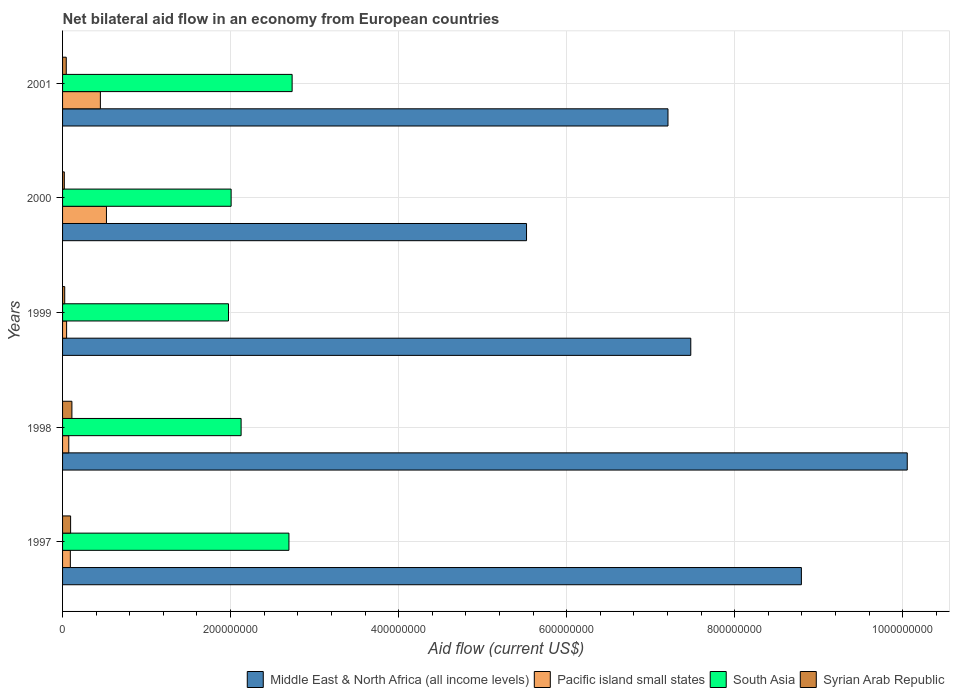How many different coloured bars are there?
Keep it short and to the point. 4. How many groups of bars are there?
Ensure brevity in your answer.  5. Are the number of bars on each tick of the Y-axis equal?
Ensure brevity in your answer.  Yes. How many bars are there on the 4th tick from the top?
Make the answer very short. 4. In how many cases, is the number of bars for a given year not equal to the number of legend labels?
Ensure brevity in your answer.  0. What is the net bilateral aid flow in Pacific island small states in 2001?
Provide a succinct answer. 4.50e+07. Across all years, what is the maximum net bilateral aid flow in Pacific island small states?
Give a very brief answer. 5.22e+07. Across all years, what is the minimum net bilateral aid flow in South Asia?
Offer a terse response. 1.98e+08. In which year was the net bilateral aid flow in South Asia maximum?
Offer a terse response. 2001. In which year was the net bilateral aid flow in Middle East & North Africa (all income levels) minimum?
Keep it short and to the point. 2000. What is the total net bilateral aid flow in Middle East & North Africa (all income levels) in the graph?
Provide a short and direct response. 3.91e+09. What is the difference between the net bilateral aid flow in South Asia in 1997 and that in 1998?
Keep it short and to the point. 5.69e+07. What is the difference between the net bilateral aid flow in Pacific island small states in 1997 and the net bilateral aid flow in Middle East & North Africa (all income levels) in 1999?
Offer a very short reply. -7.39e+08. What is the average net bilateral aid flow in South Asia per year?
Your response must be concise. 2.31e+08. In the year 1997, what is the difference between the net bilateral aid flow in South Asia and net bilateral aid flow in Middle East & North Africa (all income levels)?
Your response must be concise. -6.10e+08. What is the ratio of the net bilateral aid flow in Middle East & North Africa (all income levels) in 1999 to that in 2001?
Your answer should be compact. 1.04. Is the net bilateral aid flow in South Asia in 1997 less than that in 1998?
Make the answer very short. No. What is the difference between the highest and the second highest net bilateral aid flow in Pacific island small states?
Provide a succinct answer. 7.24e+06. What is the difference between the highest and the lowest net bilateral aid flow in Middle East & North Africa (all income levels)?
Your answer should be very brief. 4.53e+08. Is the sum of the net bilateral aid flow in Middle East & North Africa (all income levels) in 2000 and 2001 greater than the maximum net bilateral aid flow in Syrian Arab Republic across all years?
Provide a short and direct response. Yes. Is it the case that in every year, the sum of the net bilateral aid flow in Middle East & North Africa (all income levels) and net bilateral aid flow in Pacific island small states is greater than the sum of net bilateral aid flow in South Asia and net bilateral aid flow in Syrian Arab Republic?
Offer a terse response. No. What does the 1st bar from the top in 1998 represents?
Offer a very short reply. Syrian Arab Republic. What does the 1st bar from the bottom in 2000 represents?
Give a very brief answer. Middle East & North Africa (all income levels). How many bars are there?
Provide a short and direct response. 20. Does the graph contain any zero values?
Provide a short and direct response. No. How are the legend labels stacked?
Offer a very short reply. Horizontal. What is the title of the graph?
Ensure brevity in your answer.  Net bilateral aid flow in an economy from European countries. Does "Namibia" appear as one of the legend labels in the graph?
Provide a succinct answer. No. What is the label or title of the Y-axis?
Your answer should be compact. Years. What is the Aid flow (current US$) in Middle East & North Africa (all income levels) in 1997?
Your answer should be compact. 8.79e+08. What is the Aid flow (current US$) of Pacific island small states in 1997?
Make the answer very short. 9.26e+06. What is the Aid flow (current US$) in South Asia in 1997?
Ensure brevity in your answer.  2.69e+08. What is the Aid flow (current US$) of Syrian Arab Republic in 1997?
Ensure brevity in your answer.  9.58e+06. What is the Aid flow (current US$) in Middle East & North Africa (all income levels) in 1998?
Offer a terse response. 1.01e+09. What is the Aid flow (current US$) in Pacific island small states in 1998?
Give a very brief answer. 7.39e+06. What is the Aid flow (current US$) of South Asia in 1998?
Make the answer very short. 2.13e+08. What is the Aid flow (current US$) in Syrian Arab Republic in 1998?
Keep it short and to the point. 1.11e+07. What is the Aid flow (current US$) of Middle East & North Africa (all income levels) in 1999?
Ensure brevity in your answer.  7.48e+08. What is the Aid flow (current US$) in Pacific island small states in 1999?
Ensure brevity in your answer.  4.82e+06. What is the Aid flow (current US$) in South Asia in 1999?
Offer a terse response. 1.98e+08. What is the Aid flow (current US$) in Syrian Arab Republic in 1999?
Offer a terse response. 2.57e+06. What is the Aid flow (current US$) in Middle East & North Africa (all income levels) in 2000?
Your response must be concise. 5.52e+08. What is the Aid flow (current US$) of Pacific island small states in 2000?
Ensure brevity in your answer.  5.22e+07. What is the Aid flow (current US$) of South Asia in 2000?
Keep it short and to the point. 2.01e+08. What is the Aid flow (current US$) of Syrian Arab Republic in 2000?
Offer a very short reply. 2.08e+06. What is the Aid flow (current US$) in Middle East & North Africa (all income levels) in 2001?
Provide a short and direct response. 7.21e+08. What is the Aid flow (current US$) in Pacific island small states in 2001?
Provide a succinct answer. 4.50e+07. What is the Aid flow (current US$) of South Asia in 2001?
Offer a very short reply. 2.73e+08. What is the Aid flow (current US$) of Syrian Arab Republic in 2001?
Provide a short and direct response. 4.40e+06. Across all years, what is the maximum Aid flow (current US$) of Middle East & North Africa (all income levels)?
Provide a succinct answer. 1.01e+09. Across all years, what is the maximum Aid flow (current US$) of Pacific island small states?
Give a very brief answer. 5.22e+07. Across all years, what is the maximum Aid flow (current US$) of South Asia?
Give a very brief answer. 2.73e+08. Across all years, what is the maximum Aid flow (current US$) in Syrian Arab Republic?
Your response must be concise. 1.11e+07. Across all years, what is the minimum Aid flow (current US$) in Middle East & North Africa (all income levels)?
Provide a succinct answer. 5.52e+08. Across all years, what is the minimum Aid flow (current US$) in Pacific island small states?
Your answer should be compact. 4.82e+06. Across all years, what is the minimum Aid flow (current US$) in South Asia?
Provide a short and direct response. 1.98e+08. Across all years, what is the minimum Aid flow (current US$) in Syrian Arab Republic?
Offer a very short reply. 2.08e+06. What is the total Aid flow (current US$) in Middle East & North Africa (all income levels) in the graph?
Keep it short and to the point. 3.91e+09. What is the total Aid flow (current US$) in Pacific island small states in the graph?
Give a very brief answer. 1.19e+08. What is the total Aid flow (current US$) in South Asia in the graph?
Give a very brief answer. 1.15e+09. What is the total Aid flow (current US$) of Syrian Arab Republic in the graph?
Ensure brevity in your answer.  2.98e+07. What is the difference between the Aid flow (current US$) in Middle East & North Africa (all income levels) in 1997 and that in 1998?
Offer a very short reply. -1.26e+08. What is the difference between the Aid flow (current US$) of Pacific island small states in 1997 and that in 1998?
Provide a succinct answer. 1.87e+06. What is the difference between the Aid flow (current US$) in South Asia in 1997 and that in 1998?
Make the answer very short. 5.69e+07. What is the difference between the Aid flow (current US$) of Syrian Arab Republic in 1997 and that in 1998?
Your answer should be compact. -1.54e+06. What is the difference between the Aid flow (current US$) in Middle East & North Africa (all income levels) in 1997 and that in 1999?
Your response must be concise. 1.32e+08. What is the difference between the Aid flow (current US$) of Pacific island small states in 1997 and that in 1999?
Your response must be concise. 4.44e+06. What is the difference between the Aid flow (current US$) in South Asia in 1997 and that in 1999?
Your response must be concise. 7.20e+07. What is the difference between the Aid flow (current US$) in Syrian Arab Republic in 1997 and that in 1999?
Give a very brief answer. 7.01e+06. What is the difference between the Aid flow (current US$) in Middle East & North Africa (all income levels) in 1997 and that in 2000?
Provide a short and direct response. 3.27e+08. What is the difference between the Aid flow (current US$) of Pacific island small states in 1997 and that in 2000?
Your answer should be very brief. -4.30e+07. What is the difference between the Aid flow (current US$) of South Asia in 1997 and that in 2000?
Give a very brief answer. 6.88e+07. What is the difference between the Aid flow (current US$) of Syrian Arab Republic in 1997 and that in 2000?
Your response must be concise. 7.50e+06. What is the difference between the Aid flow (current US$) of Middle East & North Africa (all income levels) in 1997 and that in 2001?
Provide a short and direct response. 1.59e+08. What is the difference between the Aid flow (current US$) of Pacific island small states in 1997 and that in 2001?
Provide a short and direct response. -3.57e+07. What is the difference between the Aid flow (current US$) in South Asia in 1997 and that in 2001?
Give a very brief answer. -3.80e+06. What is the difference between the Aid flow (current US$) of Syrian Arab Republic in 1997 and that in 2001?
Make the answer very short. 5.18e+06. What is the difference between the Aid flow (current US$) in Middle East & North Africa (all income levels) in 1998 and that in 1999?
Your answer should be compact. 2.58e+08. What is the difference between the Aid flow (current US$) in Pacific island small states in 1998 and that in 1999?
Offer a very short reply. 2.57e+06. What is the difference between the Aid flow (current US$) in South Asia in 1998 and that in 1999?
Your answer should be very brief. 1.50e+07. What is the difference between the Aid flow (current US$) in Syrian Arab Republic in 1998 and that in 1999?
Provide a succinct answer. 8.55e+06. What is the difference between the Aid flow (current US$) of Middle East & North Africa (all income levels) in 1998 and that in 2000?
Offer a terse response. 4.53e+08. What is the difference between the Aid flow (current US$) in Pacific island small states in 1998 and that in 2000?
Keep it short and to the point. -4.48e+07. What is the difference between the Aid flow (current US$) of South Asia in 1998 and that in 2000?
Offer a very short reply. 1.19e+07. What is the difference between the Aid flow (current US$) in Syrian Arab Republic in 1998 and that in 2000?
Offer a very short reply. 9.04e+06. What is the difference between the Aid flow (current US$) of Middle East & North Africa (all income levels) in 1998 and that in 2001?
Provide a succinct answer. 2.85e+08. What is the difference between the Aid flow (current US$) in Pacific island small states in 1998 and that in 2001?
Your answer should be compact. -3.76e+07. What is the difference between the Aid flow (current US$) in South Asia in 1998 and that in 2001?
Provide a short and direct response. -6.07e+07. What is the difference between the Aid flow (current US$) of Syrian Arab Republic in 1998 and that in 2001?
Your answer should be very brief. 6.72e+06. What is the difference between the Aid flow (current US$) of Middle East & North Africa (all income levels) in 1999 and that in 2000?
Keep it short and to the point. 1.96e+08. What is the difference between the Aid flow (current US$) of Pacific island small states in 1999 and that in 2000?
Give a very brief answer. -4.74e+07. What is the difference between the Aid flow (current US$) in South Asia in 1999 and that in 2000?
Offer a terse response. -3.14e+06. What is the difference between the Aid flow (current US$) of Middle East & North Africa (all income levels) in 1999 and that in 2001?
Make the answer very short. 2.71e+07. What is the difference between the Aid flow (current US$) in Pacific island small states in 1999 and that in 2001?
Make the answer very short. -4.02e+07. What is the difference between the Aid flow (current US$) in South Asia in 1999 and that in 2001?
Ensure brevity in your answer.  -7.58e+07. What is the difference between the Aid flow (current US$) of Syrian Arab Republic in 1999 and that in 2001?
Your answer should be compact. -1.83e+06. What is the difference between the Aid flow (current US$) in Middle East & North Africa (all income levels) in 2000 and that in 2001?
Provide a short and direct response. -1.68e+08. What is the difference between the Aid flow (current US$) in Pacific island small states in 2000 and that in 2001?
Keep it short and to the point. 7.24e+06. What is the difference between the Aid flow (current US$) of South Asia in 2000 and that in 2001?
Your answer should be very brief. -7.26e+07. What is the difference between the Aid flow (current US$) of Syrian Arab Republic in 2000 and that in 2001?
Offer a terse response. -2.32e+06. What is the difference between the Aid flow (current US$) in Middle East & North Africa (all income levels) in 1997 and the Aid flow (current US$) in Pacific island small states in 1998?
Your answer should be compact. 8.72e+08. What is the difference between the Aid flow (current US$) in Middle East & North Africa (all income levels) in 1997 and the Aid flow (current US$) in South Asia in 1998?
Your answer should be compact. 6.67e+08. What is the difference between the Aid flow (current US$) in Middle East & North Africa (all income levels) in 1997 and the Aid flow (current US$) in Syrian Arab Republic in 1998?
Provide a short and direct response. 8.68e+08. What is the difference between the Aid flow (current US$) of Pacific island small states in 1997 and the Aid flow (current US$) of South Asia in 1998?
Give a very brief answer. -2.03e+08. What is the difference between the Aid flow (current US$) in Pacific island small states in 1997 and the Aid flow (current US$) in Syrian Arab Republic in 1998?
Your answer should be compact. -1.86e+06. What is the difference between the Aid flow (current US$) in South Asia in 1997 and the Aid flow (current US$) in Syrian Arab Republic in 1998?
Your answer should be very brief. 2.58e+08. What is the difference between the Aid flow (current US$) of Middle East & North Africa (all income levels) in 1997 and the Aid flow (current US$) of Pacific island small states in 1999?
Provide a short and direct response. 8.75e+08. What is the difference between the Aid flow (current US$) of Middle East & North Africa (all income levels) in 1997 and the Aid flow (current US$) of South Asia in 1999?
Your answer should be very brief. 6.82e+08. What is the difference between the Aid flow (current US$) of Middle East & North Africa (all income levels) in 1997 and the Aid flow (current US$) of Syrian Arab Republic in 1999?
Your answer should be compact. 8.77e+08. What is the difference between the Aid flow (current US$) of Pacific island small states in 1997 and the Aid flow (current US$) of South Asia in 1999?
Ensure brevity in your answer.  -1.88e+08. What is the difference between the Aid flow (current US$) of Pacific island small states in 1997 and the Aid flow (current US$) of Syrian Arab Republic in 1999?
Provide a short and direct response. 6.69e+06. What is the difference between the Aid flow (current US$) in South Asia in 1997 and the Aid flow (current US$) in Syrian Arab Republic in 1999?
Make the answer very short. 2.67e+08. What is the difference between the Aid flow (current US$) in Middle East & North Africa (all income levels) in 1997 and the Aid flow (current US$) in Pacific island small states in 2000?
Provide a succinct answer. 8.27e+08. What is the difference between the Aid flow (current US$) in Middle East & North Africa (all income levels) in 1997 and the Aid flow (current US$) in South Asia in 2000?
Keep it short and to the point. 6.79e+08. What is the difference between the Aid flow (current US$) of Middle East & North Africa (all income levels) in 1997 and the Aid flow (current US$) of Syrian Arab Republic in 2000?
Offer a terse response. 8.77e+08. What is the difference between the Aid flow (current US$) in Pacific island small states in 1997 and the Aid flow (current US$) in South Asia in 2000?
Provide a short and direct response. -1.91e+08. What is the difference between the Aid flow (current US$) in Pacific island small states in 1997 and the Aid flow (current US$) in Syrian Arab Republic in 2000?
Your answer should be compact. 7.18e+06. What is the difference between the Aid flow (current US$) in South Asia in 1997 and the Aid flow (current US$) in Syrian Arab Republic in 2000?
Make the answer very short. 2.67e+08. What is the difference between the Aid flow (current US$) of Middle East & North Africa (all income levels) in 1997 and the Aid flow (current US$) of Pacific island small states in 2001?
Keep it short and to the point. 8.34e+08. What is the difference between the Aid flow (current US$) in Middle East & North Africa (all income levels) in 1997 and the Aid flow (current US$) in South Asia in 2001?
Your answer should be compact. 6.06e+08. What is the difference between the Aid flow (current US$) of Middle East & North Africa (all income levels) in 1997 and the Aid flow (current US$) of Syrian Arab Republic in 2001?
Provide a succinct answer. 8.75e+08. What is the difference between the Aid flow (current US$) of Pacific island small states in 1997 and the Aid flow (current US$) of South Asia in 2001?
Provide a short and direct response. -2.64e+08. What is the difference between the Aid flow (current US$) in Pacific island small states in 1997 and the Aid flow (current US$) in Syrian Arab Republic in 2001?
Offer a terse response. 4.86e+06. What is the difference between the Aid flow (current US$) in South Asia in 1997 and the Aid flow (current US$) in Syrian Arab Republic in 2001?
Provide a succinct answer. 2.65e+08. What is the difference between the Aid flow (current US$) of Middle East & North Africa (all income levels) in 1998 and the Aid flow (current US$) of Pacific island small states in 1999?
Ensure brevity in your answer.  1.00e+09. What is the difference between the Aid flow (current US$) of Middle East & North Africa (all income levels) in 1998 and the Aid flow (current US$) of South Asia in 1999?
Make the answer very short. 8.08e+08. What is the difference between the Aid flow (current US$) of Middle East & North Africa (all income levels) in 1998 and the Aid flow (current US$) of Syrian Arab Republic in 1999?
Provide a short and direct response. 1.00e+09. What is the difference between the Aid flow (current US$) in Pacific island small states in 1998 and the Aid flow (current US$) in South Asia in 1999?
Ensure brevity in your answer.  -1.90e+08. What is the difference between the Aid flow (current US$) in Pacific island small states in 1998 and the Aid flow (current US$) in Syrian Arab Republic in 1999?
Your answer should be very brief. 4.82e+06. What is the difference between the Aid flow (current US$) in South Asia in 1998 and the Aid flow (current US$) in Syrian Arab Republic in 1999?
Your response must be concise. 2.10e+08. What is the difference between the Aid flow (current US$) of Middle East & North Africa (all income levels) in 1998 and the Aid flow (current US$) of Pacific island small states in 2000?
Your answer should be compact. 9.53e+08. What is the difference between the Aid flow (current US$) in Middle East & North Africa (all income levels) in 1998 and the Aid flow (current US$) in South Asia in 2000?
Keep it short and to the point. 8.05e+08. What is the difference between the Aid flow (current US$) of Middle East & North Africa (all income levels) in 1998 and the Aid flow (current US$) of Syrian Arab Republic in 2000?
Offer a terse response. 1.00e+09. What is the difference between the Aid flow (current US$) of Pacific island small states in 1998 and the Aid flow (current US$) of South Asia in 2000?
Make the answer very short. -1.93e+08. What is the difference between the Aid flow (current US$) of Pacific island small states in 1998 and the Aid flow (current US$) of Syrian Arab Republic in 2000?
Offer a very short reply. 5.31e+06. What is the difference between the Aid flow (current US$) of South Asia in 1998 and the Aid flow (current US$) of Syrian Arab Republic in 2000?
Your response must be concise. 2.10e+08. What is the difference between the Aid flow (current US$) of Middle East & North Africa (all income levels) in 1998 and the Aid flow (current US$) of Pacific island small states in 2001?
Make the answer very short. 9.60e+08. What is the difference between the Aid flow (current US$) of Middle East & North Africa (all income levels) in 1998 and the Aid flow (current US$) of South Asia in 2001?
Your response must be concise. 7.32e+08. What is the difference between the Aid flow (current US$) in Middle East & North Africa (all income levels) in 1998 and the Aid flow (current US$) in Syrian Arab Republic in 2001?
Your answer should be compact. 1.00e+09. What is the difference between the Aid flow (current US$) of Pacific island small states in 1998 and the Aid flow (current US$) of South Asia in 2001?
Give a very brief answer. -2.66e+08. What is the difference between the Aid flow (current US$) in Pacific island small states in 1998 and the Aid flow (current US$) in Syrian Arab Republic in 2001?
Keep it short and to the point. 2.99e+06. What is the difference between the Aid flow (current US$) in South Asia in 1998 and the Aid flow (current US$) in Syrian Arab Republic in 2001?
Your answer should be very brief. 2.08e+08. What is the difference between the Aid flow (current US$) in Middle East & North Africa (all income levels) in 1999 and the Aid flow (current US$) in Pacific island small states in 2000?
Provide a short and direct response. 6.96e+08. What is the difference between the Aid flow (current US$) in Middle East & North Africa (all income levels) in 1999 and the Aid flow (current US$) in South Asia in 2000?
Ensure brevity in your answer.  5.47e+08. What is the difference between the Aid flow (current US$) in Middle East & North Africa (all income levels) in 1999 and the Aid flow (current US$) in Syrian Arab Republic in 2000?
Your answer should be very brief. 7.46e+08. What is the difference between the Aid flow (current US$) in Pacific island small states in 1999 and the Aid flow (current US$) in South Asia in 2000?
Offer a very short reply. -1.96e+08. What is the difference between the Aid flow (current US$) of Pacific island small states in 1999 and the Aid flow (current US$) of Syrian Arab Republic in 2000?
Offer a very short reply. 2.74e+06. What is the difference between the Aid flow (current US$) in South Asia in 1999 and the Aid flow (current US$) in Syrian Arab Republic in 2000?
Your answer should be very brief. 1.95e+08. What is the difference between the Aid flow (current US$) of Middle East & North Africa (all income levels) in 1999 and the Aid flow (current US$) of Pacific island small states in 2001?
Offer a very short reply. 7.03e+08. What is the difference between the Aid flow (current US$) in Middle East & North Africa (all income levels) in 1999 and the Aid flow (current US$) in South Asia in 2001?
Ensure brevity in your answer.  4.75e+08. What is the difference between the Aid flow (current US$) in Middle East & North Africa (all income levels) in 1999 and the Aid flow (current US$) in Syrian Arab Republic in 2001?
Give a very brief answer. 7.43e+08. What is the difference between the Aid flow (current US$) of Pacific island small states in 1999 and the Aid flow (current US$) of South Asia in 2001?
Ensure brevity in your answer.  -2.68e+08. What is the difference between the Aid flow (current US$) in Pacific island small states in 1999 and the Aid flow (current US$) in Syrian Arab Republic in 2001?
Ensure brevity in your answer.  4.20e+05. What is the difference between the Aid flow (current US$) of South Asia in 1999 and the Aid flow (current US$) of Syrian Arab Republic in 2001?
Give a very brief answer. 1.93e+08. What is the difference between the Aid flow (current US$) of Middle East & North Africa (all income levels) in 2000 and the Aid flow (current US$) of Pacific island small states in 2001?
Give a very brief answer. 5.07e+08. What is the difference between the Aid flow (current US$) of Middle East & North Africa (all income levels) in 2000 and the Aid flow (current US$) of South Asia in 2001?
Make the answer very short. 2.79e+08. What is the difference between the Aid flow (current US$) in Middle East & North Africa (all income levels) in 2000 and the Aid flow (current US$) in Syrian Arab Republic in 2001?
Offer a very short reply. 5.48e+08. What is the difference between the Aid flow (current US$) in Pacific island small states in 2000 and the Aid flow (current US$) in South Asia in 2001?
Offer a terse response. -2.21e+08. What is the difference between the Aid flow (current US$) in Pacific island small states in 2000 and the Aid flow (current US$) in Syrian Arab Republic in 2001?
Offer a terse response. 4.78e+07. What is the difference between the Aid flow (current US$) of South Asia in 2000 and the Aid flow (current US$) of Syrian Arab Republic in 2001?
Offer a terse response. 1.96e+08. What is the average Aid flow (current US$) of Middle East & North Africa (all income levels) per year?
Offer a very short reply. 7.81e+08. What is the average Aid flow (current US$) in Pacific island small states per year?
Keep it short and to the point. 2.37e+07. What is the average Aid flow (current US$) of South Asia per year?
Ensure brevity in your answer.  2.31e+08. What is the average Aid flow (current US$) in Syrian Arab Republic per year?
Provide a succinct answer. 5.95e+06. In the year 1997, what is the difference between the Aid flow (current US$) of Middle East & North Africa (all income levels) and Aid flow (current US$) of Pacific island small states?
Keep it short and to the point. 8.70e+08. In the year 1997, what is the difference between the Aid flow (current US$) of Middle East & North Africa (all income levels) and Aid flow (current US$) of South Asia?
Your answer should be compact. 6.10e+08. In the year 1997, what is the difference between the Aid flow (current US$) in Middle East & North Africa (all income levels) and Aid flow (current US$) in Syrian Arab Republic?
Give a very brief answer. 8.70e+08. In the year 1997, what is the difference between the Aid flow (current US$) in Pacific island small states and Aid flow (current US$) in South Asia?
Give a very brief answer. -2.60e+08. In the year 1997, what is the difference between the Aid flow (current US$) of Pacific island small states and Aid flow (current US$) of Syrian Arab Republic?
Offer a very short reply. -3.20e+05. In the year 1997, what is the difference between the Aid flow (current US$) in South Asia and Aid flow (current US$) in Syrian Arab Republic?
Your response must be concise. 2.60e+08. In the year 1998, what is the difference between the Aid flow (current US$) of Middle East & North Africa (all income levels) and Aid flow (current US$) of Pacific island small states?
Ensure brevity in your answer.  9.98e+08. In the year 1998, what is the difference between the Aid flow (current US$) in Middle East & North Africa (all income levels) and Aid flow (current US$) in South Asia?
Make the answer very short. 7.93e+08. In the year 1998, what is the difference between the Aid flow (current US$) in Middle East & North Africa (all income levels) and Aid flow (current US$) in Syrian Arab Republic?
Offer a very short reply. 9.94e+08. In the year 1998, what is the difference between the Aid flow (current US$) of Pacific island small states and Aid flow (current US$) of South Asia?
Your answer should be very brief. -2.05e+08. In the year 1998, what is the difference between the Aid flow (current US$) in Pacific island small states and Aid flow (current US$) in Syrian Arab Republic?
Ensure brevity in your answer.  -3.73e+06. In the year 1998, what is the difference between the Aid flow (current US$) of South Asia and Aid flow (current US$) of Syrian Arab Republic?
Give a very brief answer. 2.01e+08. In the year 1999, what is the difference between the Aid flow (current US$) of Middle East & North Africa (all income levels) and Aid flow (current US$) of Pacific island small states?
Offer a very short reply. 7.43e+08. In the year 1999, what is the difference between the Aid flow (current US$) in Middle East & North Africa (all income levels) and Aid flow (current US$) in South Asia?
Your answer should be compact. 5.50e+08. In the year 1999, what is the difference between the Aid flow (current US$) in Middle East & North Africa (all income levels) and Aid flow (current US$) in Syrian Arab Republic?
Offer a terse response. 7.45e+08. In the year 1999, what is the difference between the Aid flow (current US$) in Pacific island small states and Aid flow (current US$) in South Asia?
Keep it short and to the point. -1.93e+08. In the year 1999, what is the difference between the Aid flow (current US$) in Pacific island small states and Aid flow (current US$) in Syrian Arab Republic?
Keep it short and to the point. 2.25e+06. In the year 1999, what is the difference between the Aid flow (current US$) in South Asia and Aid flow (current US$) in Syrian Arab Republic?
Provide a short and direct response. 1.95e+08. In the year 2000, what is the difference between the Aid flow (current US$) in Middle East & North Africa (all income levels) and Aid flow (current US$) in Pacific island small states?
Provide a short and direct response. 5.00e+08. In the year 2000, what is the difference between the Aid flow (current US$) of Middle East & North Africa (all income levels) and Aid flow (current US$) of South Asia?
Offer a terse response. 3.52e+08. In the year 2000, what is the difference between the Aid flow (current US$) of Middle East & North Africa (all income levels) and Aid flow (current US$) of Syrian Arab Republic?
Keep it short and to the point. 5.50e+08. In the year 2000, what is the difference between the Aid flow (current US$) in Pacific island small states and Aid flow (current US$) in South Asia?
Your answer should be very brief. -1.48e+08. In the year 2000, what is the difference between the Aid flow (current US$) of Pacific island small states and Aid flow (current US$) of Syrian Arab Republic?
Your answer should be compact. 5.02e+07. In the year 2000, what is the difference between the Aid flow (current US$) of South Asia and Aid flow (current US$) of Syrian Arab Republic?
Your answer should be very brief. 1.99e+08. In the year 2001, what is the difference between the Aid flow (current US$) in Middle East & North Africa (all income levels) and Aid flow (current US$) in Pacific island small states?
Offer a terse response. 6.76e+08. In the year 2001, what is the difference between the Aid flow (current US$) in Middle East & North Africa (all income levels) and Aid flow (current US$) in South Asia?
Offer a terse response. 4.47e+08. In the year 2001, what is the difference between the Aid flow (current US$) of Middle East & North Africa (all income levels) and Aid flow (current US$) of Syrian Arab Republic?
Provide a short and direct response. 7.16e+08. In the year 2001, what is the difference between the Aid flow (current US$) of Pacific island small states and Aid flow (current US$) of South Asia?
Make the answer very short. -2.28e+08. In the year 2001, what is the difference between the Aid flow (current US$) of Pacific island small states and Aid flow (current US$) of Syrian Arab Republic?
Your response must be concise. 4.06e+07. In the year 2001, what is the difference between the Aid flow (current US$) of South Asia and Aid flow (current US$) of Syrian Arab Republic?
Your answer should be very brief. 2.69e+08. What is the ratio of the Aid flow (current US$) in Middle East & North Africa (all income levels) in 1997 to that in 1998?
Ensure brevity in your answer.  0.87. What is the ratio of the Aid flow (current US$) of Pacific island small states in 1997 to that in 1998?
Give a very brief answer. 1.25. What is the ratio of the Aid flow (current US$) in South Asia in 1997 to that in 1998?
Make the answer very short. 1.27. What is the ratio of the Aid flow (current US$) of Syrian Arab Republic in 1997 to that in 1998?
Offer a very short reply. 0.86. What is the ratio of the Aid flow (current US$) in Middle East & North Africa (all income levels) in 1997 to that in 1999?
Offer a very short reply. 1.18. What is the ratio of the Aid flow (current US$) in Pacific island small states in 1997 to that in 1999?
Offer a very short reply. 1.92. What is the ratio of the Aid flow (current US$) of South Asia in 1997 to that in 1999?
Your answer should be very brief. 1.36. What is the ratio of the Aid flow (current US$) in Syrian Arab Republic in 1997 to that in 1999?
Make the answer very short. 3.73. What is the ratio of the Aid flow (current US$) in Middle East & North Africa (all income levels) in 1997 to that in 2000?
Your response must be concise. 1.59. What is the ratio of the Aid flow (current US$) in Pacific island small states in 1997 to that in 2000?
Provide a short and direct response. 0.18. What is the ratio of the Aid flow (current US$) of South Asia in 1997 to that in 2000?
Your response must be concise. 1.34. What is the ratio of the Aid flow (current US$) in Syrian Arab Republic in 1997 to that in 2000?
Offer a terse response. 4.61. What is the ratio of the Aid flow (current US$) in Middle East & North Africa (all income levels) in 1997 to that in 2001?
Keep it short and to the point. 1.22. What is the ratio of the Aid flow (current US$) of Pacific island small states in 1997 to that in 2001?
Give a very brief answer. 0.21. What is the ratio of the Aid flow (current US$) of South Asia in 1997 to that in 2001?
Make the answer very short. 0.99. What is the ratio of the Aid flow (current US$) of Syrian Arab Republic in 1997 to that in 2001?
Offer a terse response. 2.18. What is the ratio of the Aid flow (current US$) in Middle East & North Africa (all income levels) in 1998 to that in 1999?
Keep it short and to the point. 1.34. What is the ratio of the Aid flow (current US$) of Pacific island small states in 1998 to that in 1999?
Keep it short and to the point. 1.53. What is the ratio of the Aid flow (current US$) of South Asia in 1998 to that in 1999?
Provide a succinct answer. 1.08. What is the ratio of the Aid flow (current US$) of Syrian Arab Republic in 1998 to that in 1999?
Your answer should be very brief. 4.33. What is the ratio of the Aid flow (current US$) in Middle East & North Africa (all income levels) in 1998 to that in 2000?
Give a very brief answer. 1.82. What is the ratio of the Aid flow (current US$) of Pacific island small states in 1998 to that in 2000?
Provide a short and direct response. 0.14. What is the ratio of the Aid flow (current US$) of South Asia in 1998 to that in 2000?
Give a very brief answer. 1.06. What is the ratio of the Aid flow (current US$) in Syrian Arab Republic in 1998 to that in 2000?
Provide a short and direct response. 5.35. What is the ratio of the Aid flow (current US$) in Middle East & North Africa (all income levels) in 1998 to that in 2001?
Offer a terse response. 1.4. What is the ratio of the Aid flow (current US$) in Pacific island small states in 1998 to that in 2001?
Offer a very short reply. 0.16. What is the ratio of the Aid flow (current US$) in Syrian Arab Republic in 1998 to that in 2001?
Provide a short and direct response. 2.53. What is the ratio of the Aid flow (current US$) of Middle East & North Africa (all income levels) in 1999 to that in 2000?
Make the answer very short. 1.35. What is the ratio of the Aid flow (current US$) of Pacific island small states in 1999 to that in 2000?
Give a very brief answer. 0.09. What is the ratio of the Aid flow (current US$) in South Asia in 1999 to that in 2000?
Provide a succinct answer. 0.98. What is the ratio of the Aid flow (current US$) of Syrian Arab Republic in 1999 to that in 2000?
Keep it short and to the point. 1.24. What is the ratio of the Aid flow (current US$) in Middle East & North Africa (all income levels) in 1999 to that in 2001?
Ensure brevity in your answer.  1.04. What is the ratio of the Aid flow (current US$) of Pacific island small states in 1999 to that in 2001?
Keep it short and to the point. 0.11. What is the ratio of the Aid flow (current US$) in South Asia in 1999 to that in 2001?
Your answer should be very brief. 0.72. What is the ratio of the Aid flow (current US$) in Syrian Arab Republic in 1999 to that in 2001?
Provide a short and direct response. 0.58. What is the ratio of the Aid flow (current US$) of Middle East & North Africa (all income levels) in 2000 to that in 2001?
Your response must be concise. 0.77. What is the ratio of the Aid flow (current US$) of Pacific island small states in 2000 to that in 2001?
Your answer should be compact. 1.16. What is the ratio of the Aid flow (current US$) of South Asia in 2000 to that in 2001?
Ensure brevity in your answer.  0.73. What is the ratio of the Aid flow (current US$) in Syrian Arab Republic in 2000 to that in 2001?
Your response must be concise. 0.47. What is the difference between the highest and the second highest Aid flow (current US$) of Middle East & North Africa (all income levels)?
Your answer should be compact. 1.26e+08. What is the difference between the highest and the second highest Aid flow (current US$) of Pacific island small states?
Give a very brief answer. 7.24e+06. What is the difference between the highest and the second highest Aid flow (current US$) in South Asia?
Your answer should be compact. 3.80e+06. What is the difference between the highest and the second highest Aid flow (current US$) in Syrian Arab Republic?
Your answer should be very brief. 1.54e+06. What is the difference between the highest and the lowest Aid flow (current US$) in Middle East & North Africa (all income levels)?
Ensure brevity in your answer.  4.53e+08. What is the difference between the highest and the lowest Aid flow (current US$) of Pacific island small states?
Give a very brief answer. 4.74e+07. What is the difference between the highest and the lowest Aid flow (current US$) of South Asia?
Give a very brief answer. 7.58e+07. What is the difference between the highest and the lowest Aid flow (current US$) of Syrian Arab Republic?
Offer a terse response. 9.04e+06. 